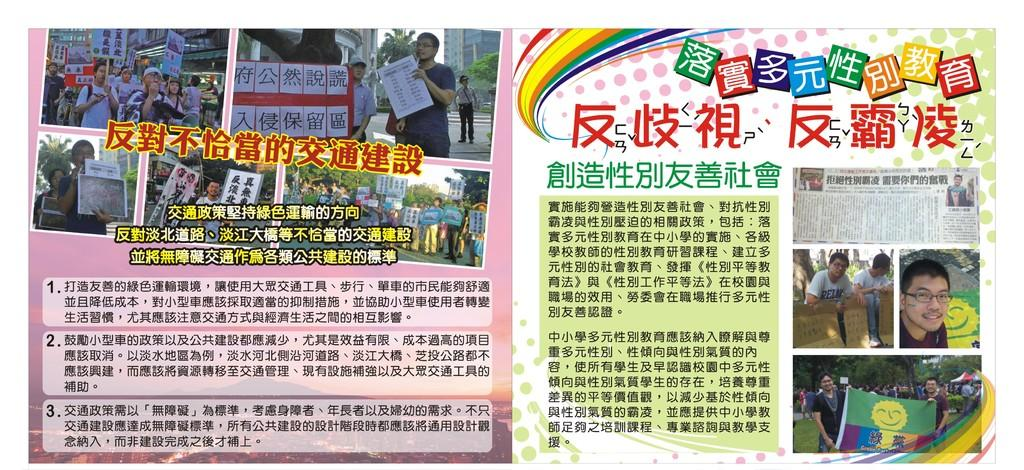What are the people in the image holding? The people in the image are holding a board with some information on it. What can be seen in the background of the image? There are trees and a building visible in the background of the image. What type of object is present in the image? An article is present in the image. Can you see any giants holding the board in the image? No, there are no giants present in the image. Are there any cherries hanging from the trees in the background? There is no mention of cherries in the image; only trees are visible in the background. 